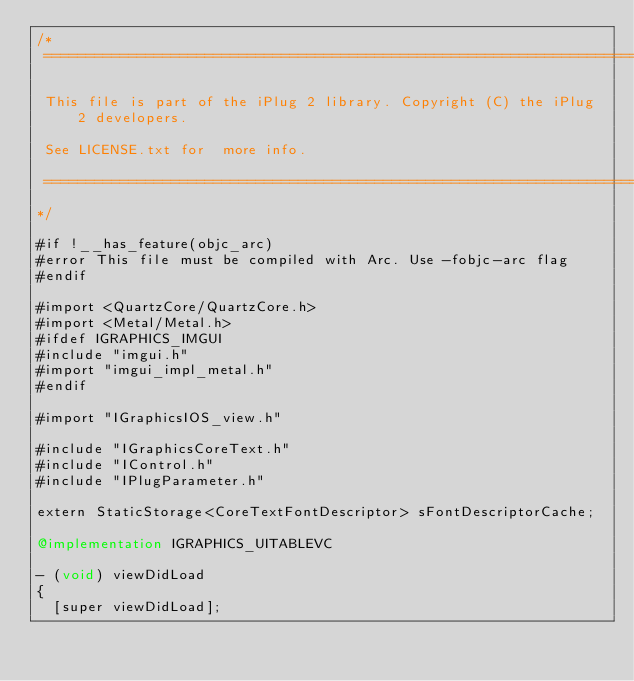<code> <loc_0><loc_0><loc_500><loc_500><_ObjectiveC_>/*
 ==============================================================================

 This file is part of the iPlug 2 library. Copyright (C) the iPlug 2 developers.

 See LICENSE.txt for  more info.

 ==============================================================================
*/

#if !__has_feature(objc_arc)
#error This file must be compiled with Arc. Use -fobjc-arc flag
#endif

#import <QuartzCore/QuartzCore.h>
#import <Metal/Metal.h>
#ifdef IGRAPHICS_IMGUI
#include "imgui.h"
#import "imgui_impl_metal.h"
#endif

#import "IGraphicsIOS_view.h"

#include "IGraphicsCoreText.h"
#include "IControl.h"
#include "IPlugParameter.h"

extern StaticStorage<CoreTextFontDescriptor> sFontDescriptorCache;

@implementation IGRAPHICS_UITABLEVC

- (void) viewDidLoad
{
  [super viewDidLoad];</code> 